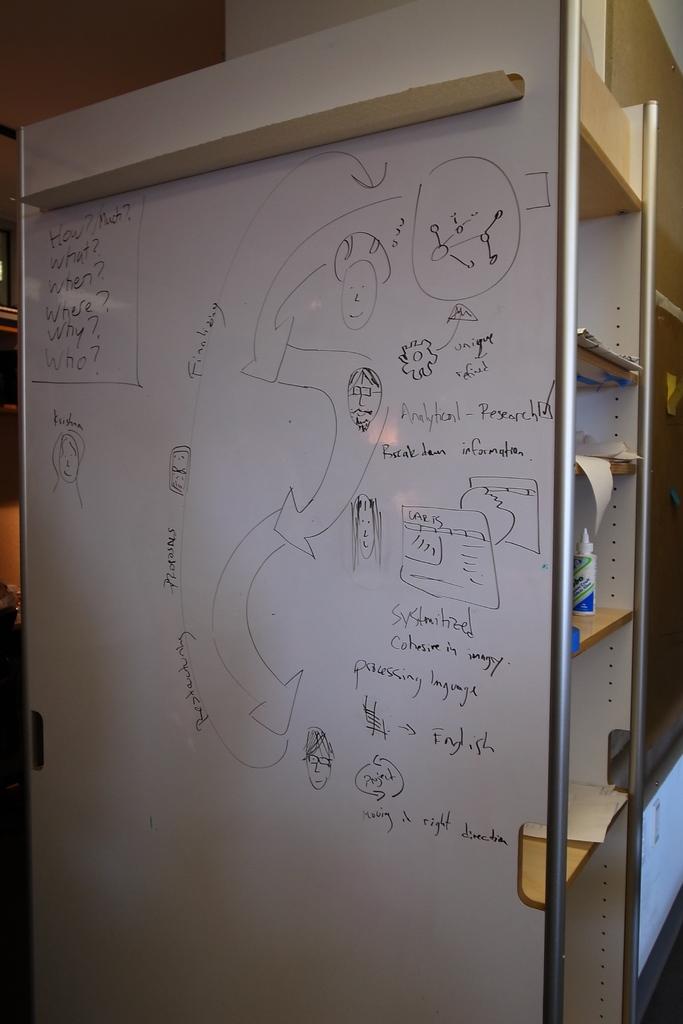What is one of the questions asked on the board?
Offer a very short reply. How?. What rirection is it moving on the bottom right?
Provide a short and direct response. Right. 